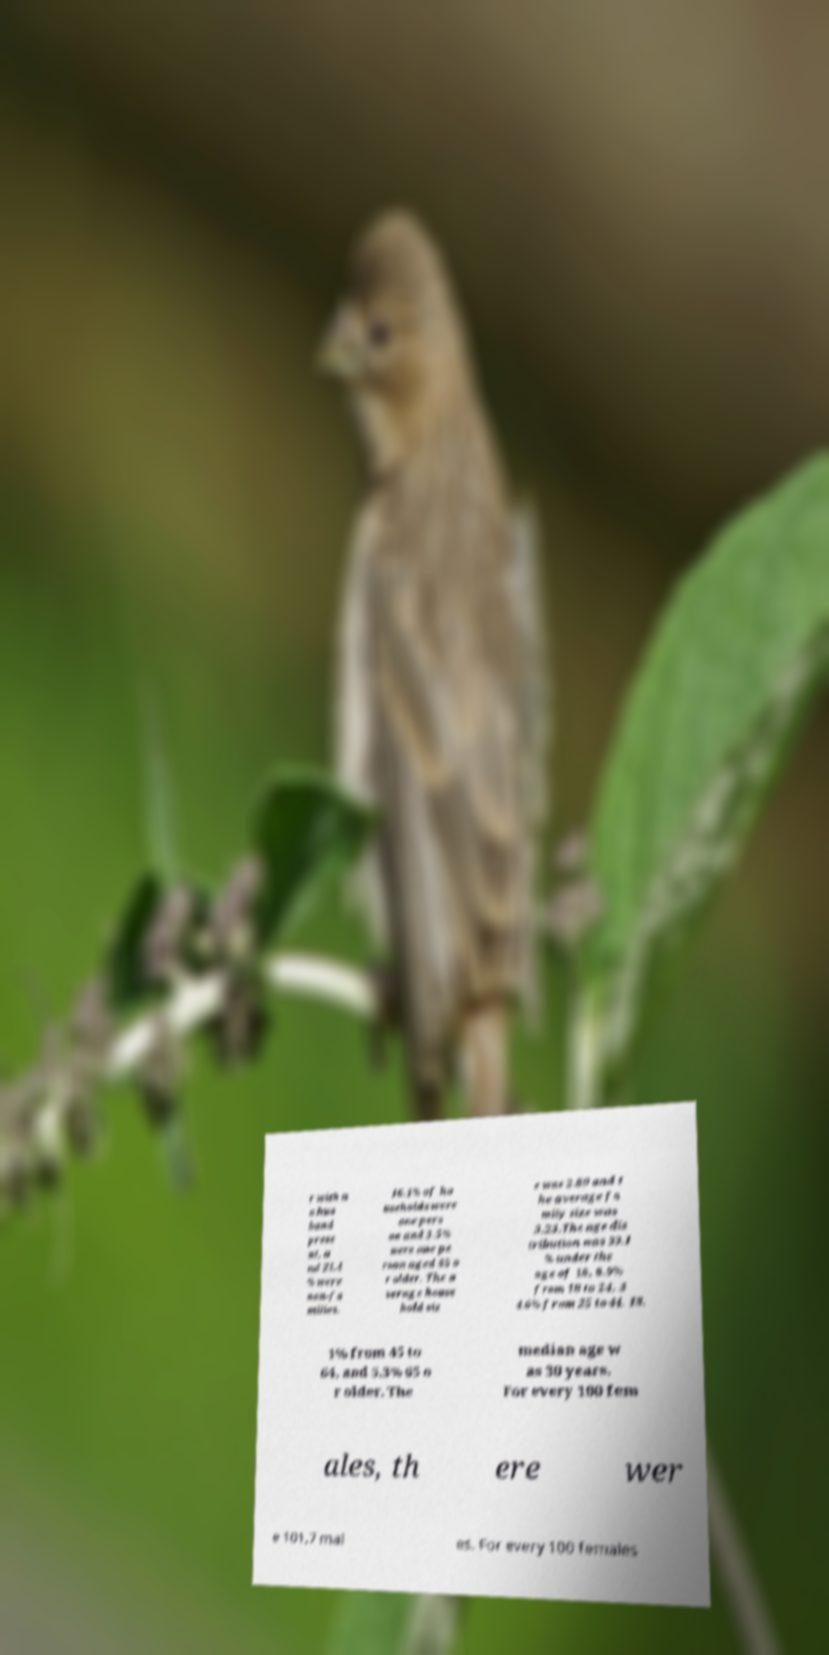There's text embedded in this image that I need extracted. Can you transcribe it verbatim? r with n o hus band prese nt, a nd 21.4 % were non-fa milies. 16.1% of ho useholds were one pers on and 3.5% were one pe rson aged 65 o r older. The a verage house hold siz e was 2.89 and t he average fa mily size was 3.23.The age dis tribution was 33.1 % under the age of 18, 8.9% from 18 to 24, 3 4.6% from 25 to 44, 18. 1% from 45 to 64, and 5.3% 65 o r older. The median age w as 30 years. For every 100 fem ales, th ere wer e 101.7 mal es. For every 100 females 